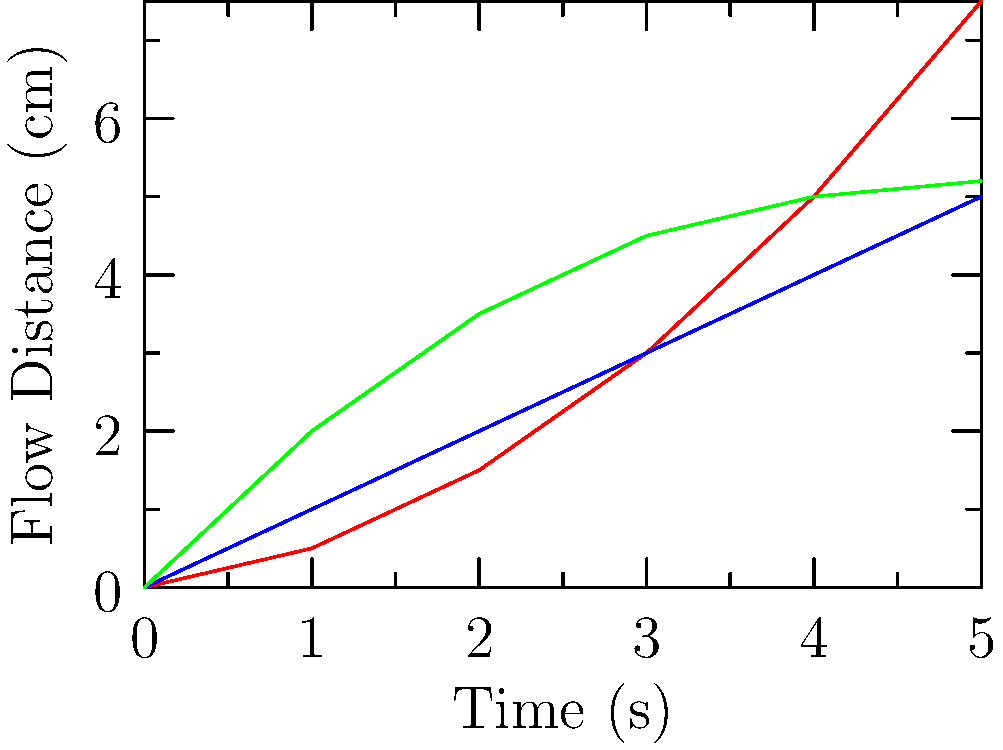Based on the flow rate diagram comparing three paint types with different viscosities, which paint would be most suitable for a cafe owner's mural project requiring detailed brushwork and slower drying time? To determine the most suitable paint for detailed brushwork and slower drying time, we need to analyze the flow rate diagram:

1. Identify the lines:
   - Red line: High Viscosity Paint
   - Blue line: Medium Viscosity Paint
   - Green line: Low Viscosity Paint

2. Interpret the graph:
   - The x-axis represents time (s)
   - The y-axis represents flow distance (cm)
   - Steeper lines indicate faster flow rates (lower viscosity)
   - Flatter lines indicate slower flow rates (higher viscosity)

3. Compare the viscosities:
   - High Viscosity Paint (red) has the flattest curve, indicating the slowest flow rate
   - Medium Viscosity Paint (blue) has a linear curve with moderate flow rate
   - Low Viscosity Paint (green) has the steepest initial curve, indicating the fastest flow rate

4. Consider the requirements:
   - Detailed brushwork requires more control, which is easier with higher viscosity paints
   - Slower drying time is typically associated with higher viscosity paints

5. Conclusion:
   The High Viscosity Paint (red line) would be most suitable for detailed brushwork and slower drying time, as it has the slowest flow rate, allowing for better control and extended working time.
Answer: High Viscosity Paint 